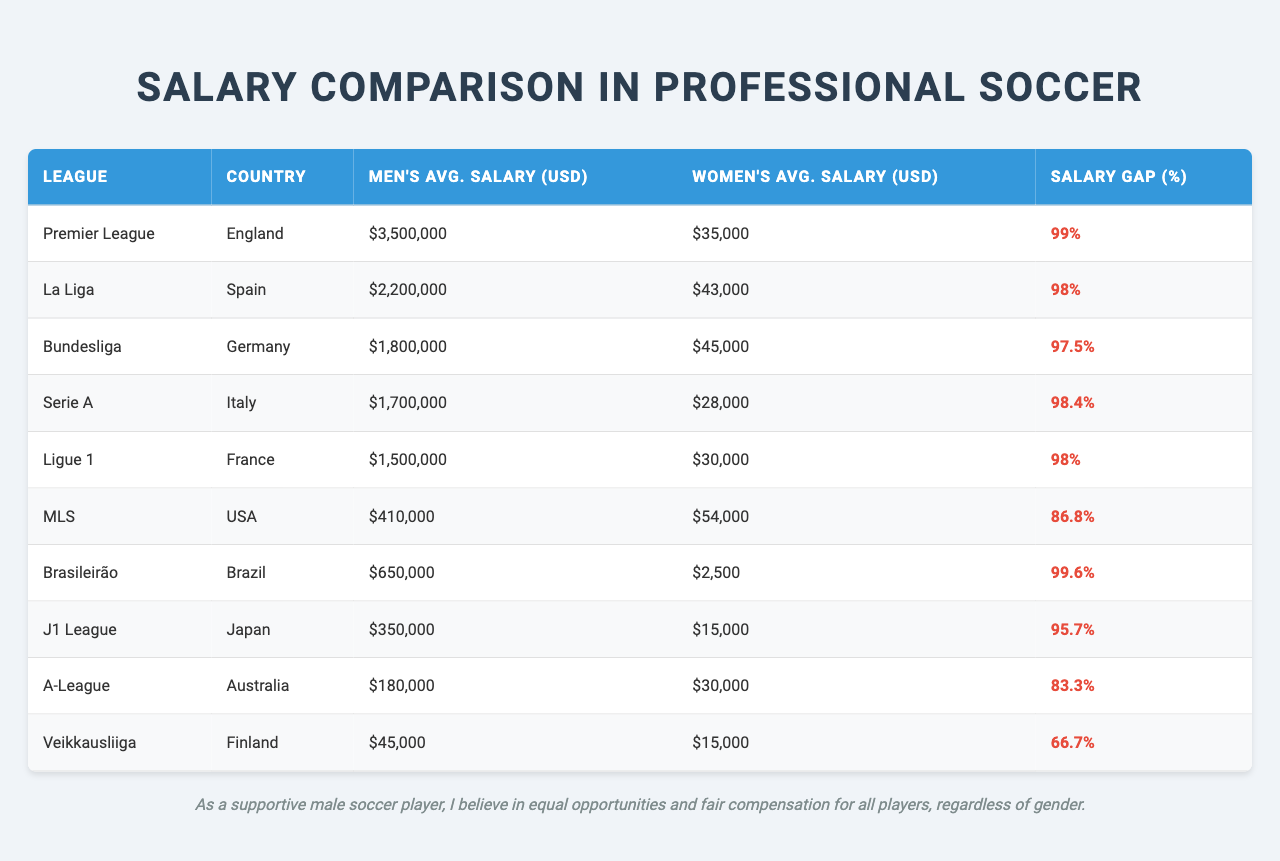What is the average men's salary in the Premier League? The table shows that the average men's salary in the Premier League is listed as $3,500,000.
Answer: $3,500,000 Which women's league has the highest average salary? In the table, the women's league with the highest average salary is the NWSL in the USA, reported as $54,000.
Answer: NWSL (USA) What is the salary gap percentage for the Bundesliga? The table indicates that the salary gap percentage for the Bundesliga is 97.5%.
Answer: 97.5% Is the average women's salary in Serie A greater than $50,000? The average women's salary for Serie A is $28,000, which is less than $50,000. Therefore, the answer is no.
Answer: No What is the difference in average salaries between men's and women's leagues in La Liga? The average men's salary in La Liga is $2,200,000, and the women's salary is $43,000. The difference is $2,200,000 - $43,000 = $2,157,000.
Answer: $2,157,000 Which league has the smallest salary gap percentage? The league with the smallest salary gap percentage is Veikkausliiga from Finland, which has a gap of 66.7%.
Answer: Veikkausliiga (Finland) If we average the men's salaries for all leagues listed, what would be the average? The total of the men's salaries is $3,500,000 + $2,200,000 + $1,800,000 + $1,700,000 + $1,500,000 + $410,000 + $650,000 + $350,000 + $180,000 + $45,000 = $12,335,000. There are 10 leagues, so the average is $12,335,000 / 10 = $1,233,500.
Answer: $1,233,500 Is Major League Soccer (MLS) the only league with a salary gap below 90%? Yes, the MLS has a salary gap of 86.8%, while all others exceed this percentage.
Answer: Yes Which country has the lowest average women's salary in professional leagues? The table shows that Brazil has the lowest average women's salary at $2,500.
Answer: Brazil What is the total average salary of women's leagues listed in the table? The total of the women's averages is $35,000 (Premier League) + $43,000 (La Liga) + $45,000 (Bundesliga) + $28,000 (Serie A) + $30,000 (Ligue 1) + $54,000 (MLS) + $2,500 (Brasileirão) + $15,000 (J1 League) + $30,000 (A-League) + $15,000 (Veikkausliiga) = $329,500. There are 10 leagues, so the average is $329,500 / 10 = $32,950.
Answer: $32,950 